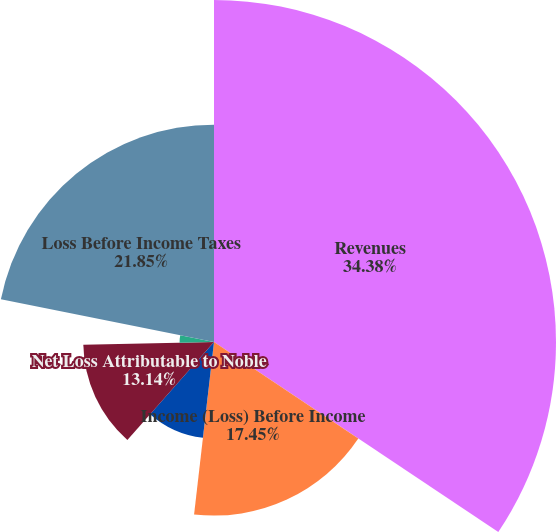<chart> <loc_0><loc_0><loc_500><loc_500><pie_chart><fcel>Revenues<fcel>Income (Loss) Before Income<fcel>Net Income (Loss)<fcel>Net Loss Attributable to Noble<fcel>Loss Per Share Basic<fcel>Loss Per Share Diluted<fcel>Loss Before Income Taxes<nl><fcel>34.38%<fcel>17.45%<fcel>9.7%<fcel>13.14%<fcel>0.02%<fcel>3.46%<fcel>21.85%<nl></chart> 